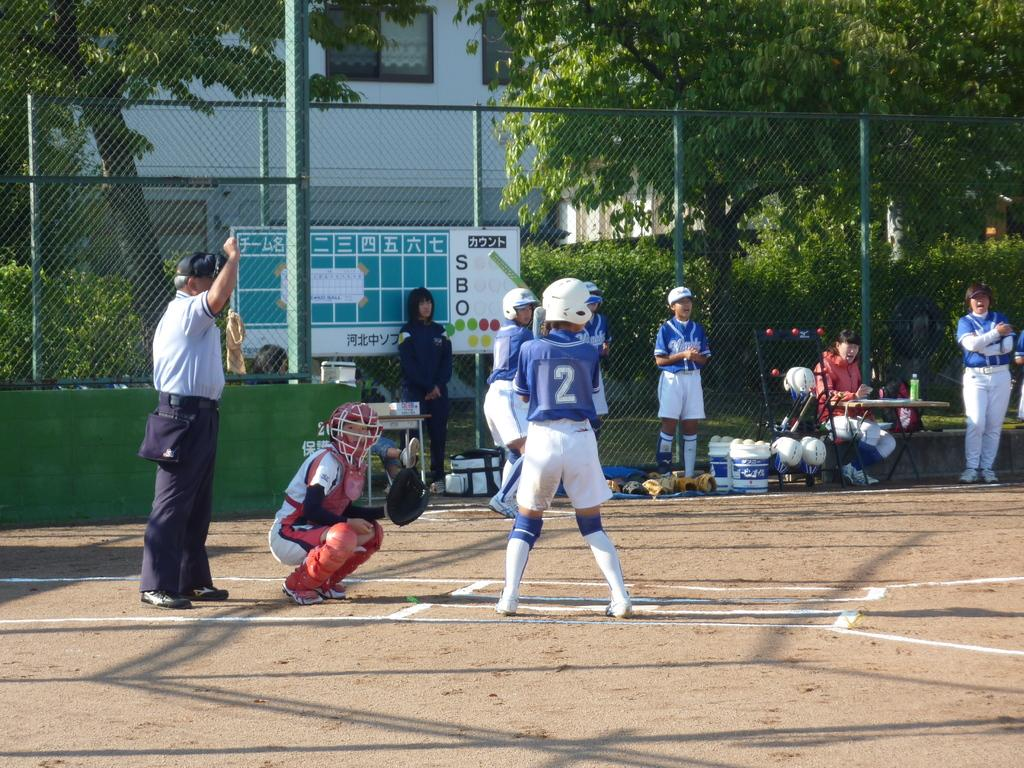Provide a one-sentence caption for the provided image. a batter getting ready to hit a ball with the number 12 on their jersey. 